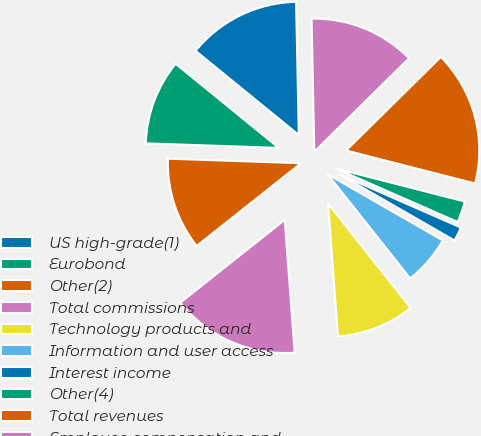Convert chart. <chart><loc_0><loc_0><loc_500><loc_500><pie_chart><fcel>US high-grade(1)<fcel>Eurobond<fcel>Other(2)<fcel>Total commissions<fcel>Technology products and<fcel>Information and user access<fcel>Interest income<fcel>Other(4)<fcel>Total revenues<fcel>Employee compensation and<nl><fcel>13.79%<fcel>10.34%<fcel>11.21%<fcel>15.52%<fcel>9.48%<fcel>6.03%<fcel>1.72%<fcel>2.59%<fcel>16.38%<fcel>12.93%<nl></chart> 